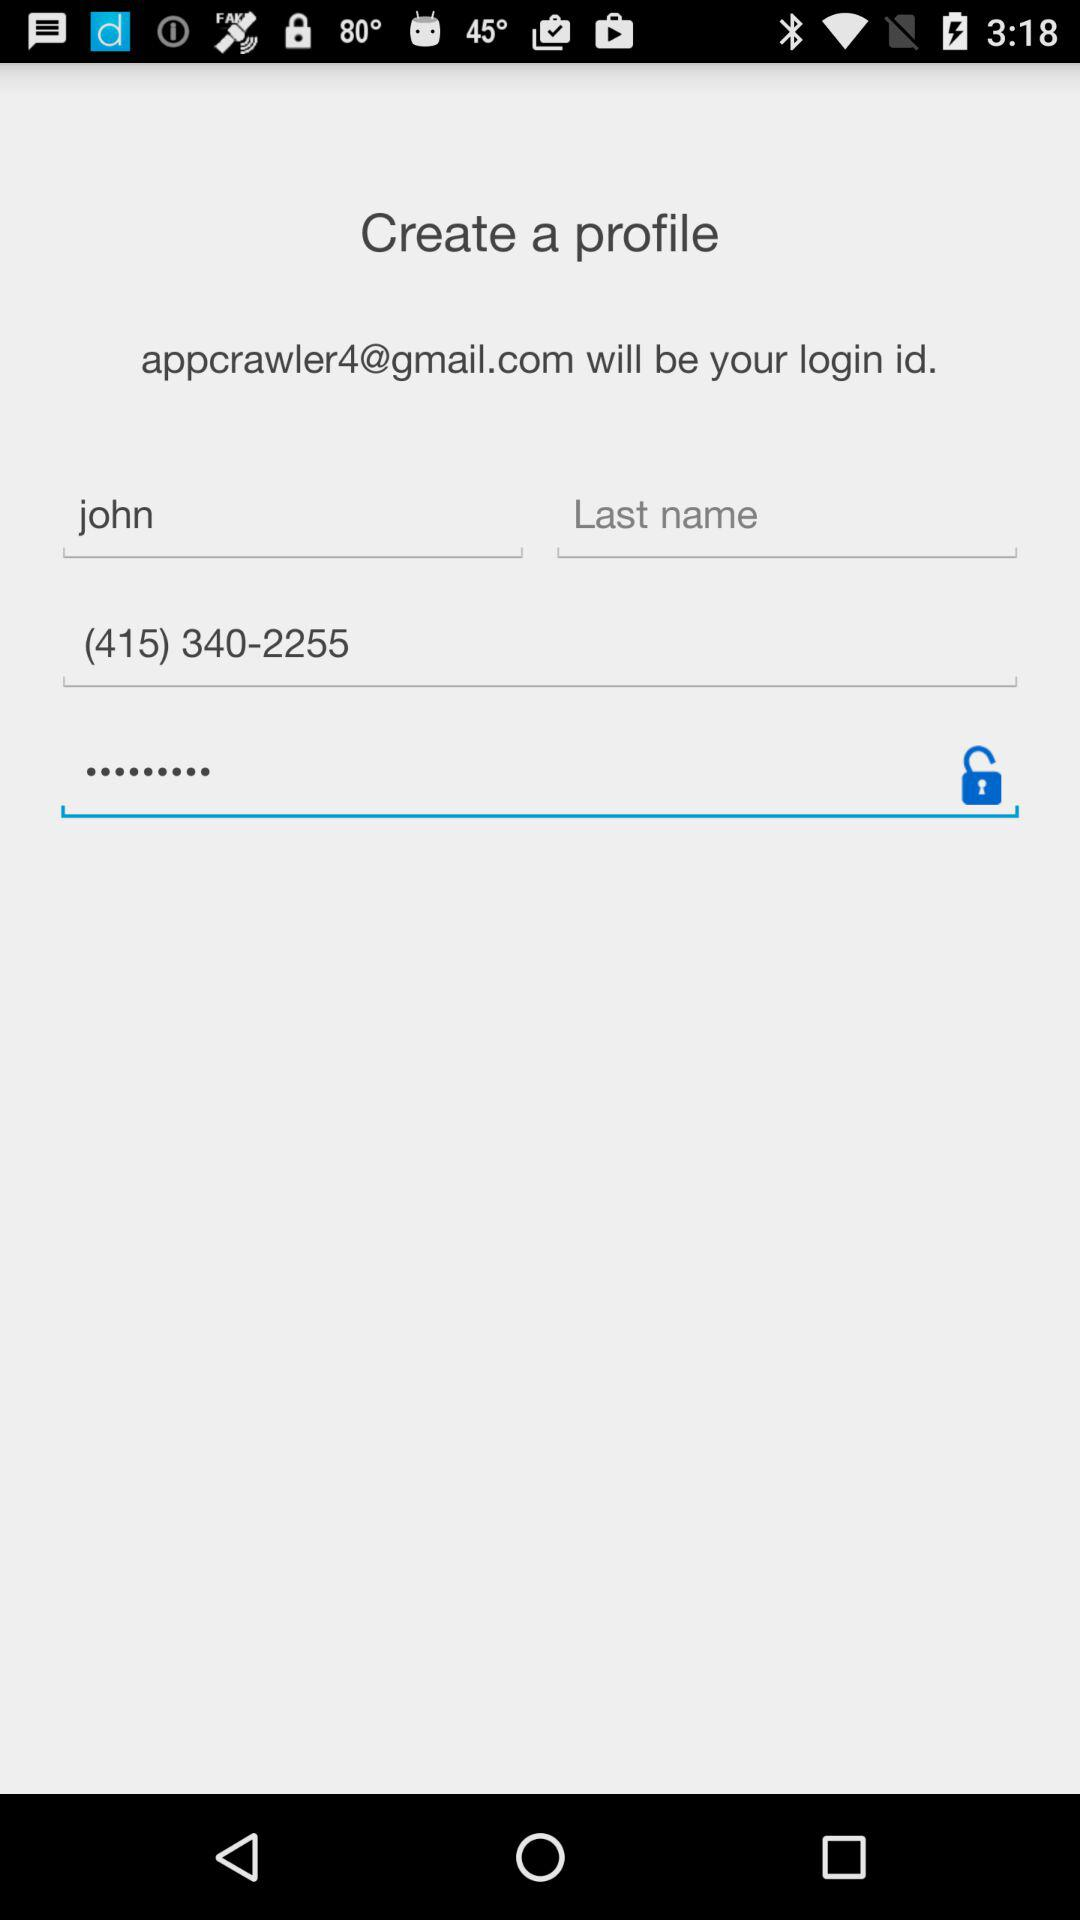What is the first name? The first name is John. 